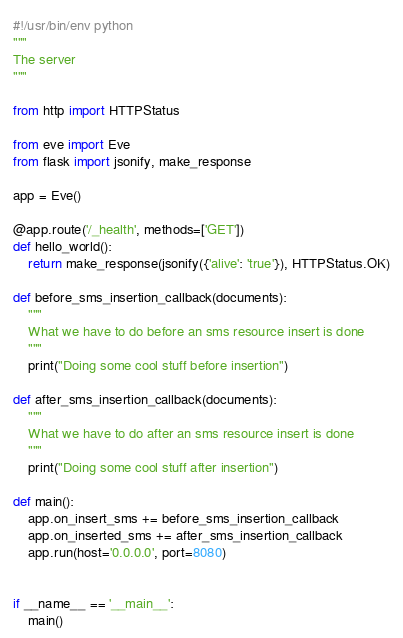Convert code to text. <code><loc_0><loc_0><loc_500><loc_500><_Python_>#!/usr/bin/env python
"""
The server
"""

from http import HTTPStatus

from eve import Eve
from flask import jsonify, make_response

app = Eve()

@app.route('/_health', methods=['GET'])
def hello_world():
    return make_response(jsonify({'alive': 'true'}), HTTPStatus.OK)

def before_sms_insertion_callback(documents):
    """
    What we have to do before an sms resource insert is done
    """
    print("Doing some cool stuff before insertion")

def after_sms_insertion_callback(documents):
    """
    What we have to do after an sms resource insert is done
    """
    print("Doing some cool stuff after insertion")
 
def main():
    app.on_insert_sms += before_sms_insertion_callback
    app.on_inserted_sms += after_sms_insertion_callback
    app.run(host='0.0.0.0', port=8080)


if __name__ == '__main__':
    main()</code> 